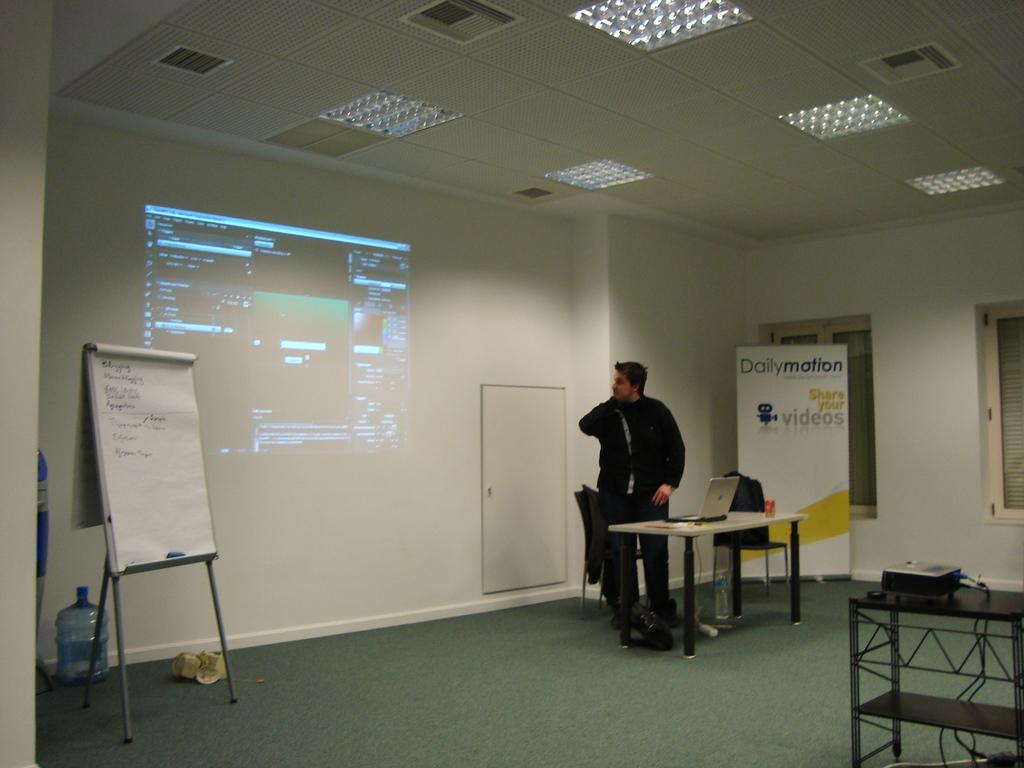<image>
Present a compact description of the photo's key features. A guy giving a presentation with a Dailymotion sign behind him. 